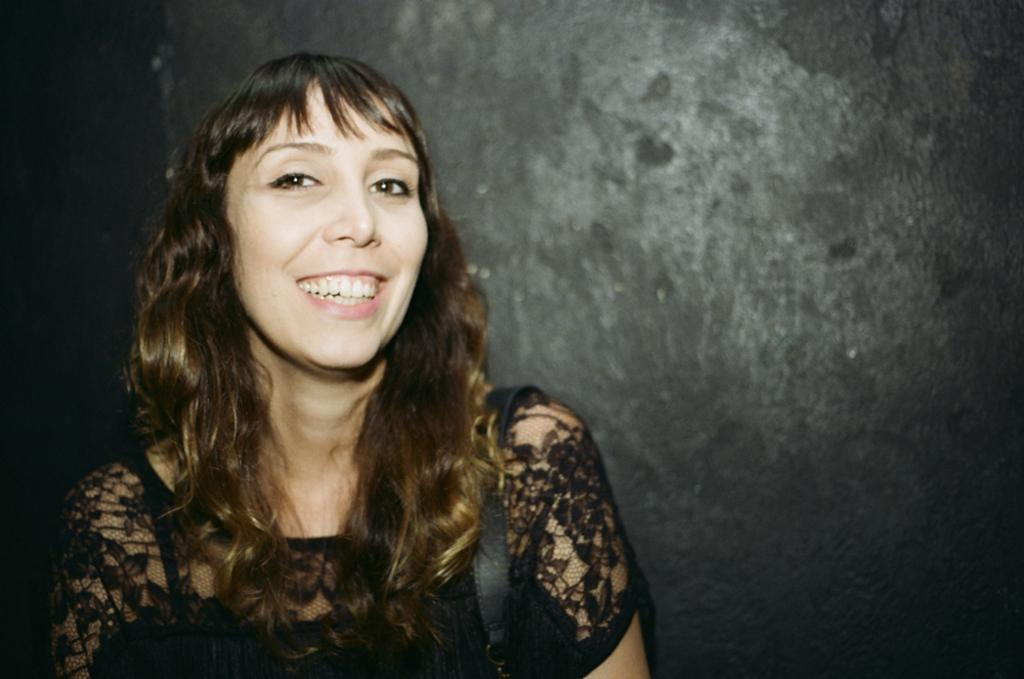Who is present in the image? There is a lady in the picture. What can be seen in the background of the image? There is a wall in the background of the picture. What type of shoes is the lady wearing in the image? The provided facts do not mention any shoes, so we cannot determine what type of shoes the lady is wearing. 